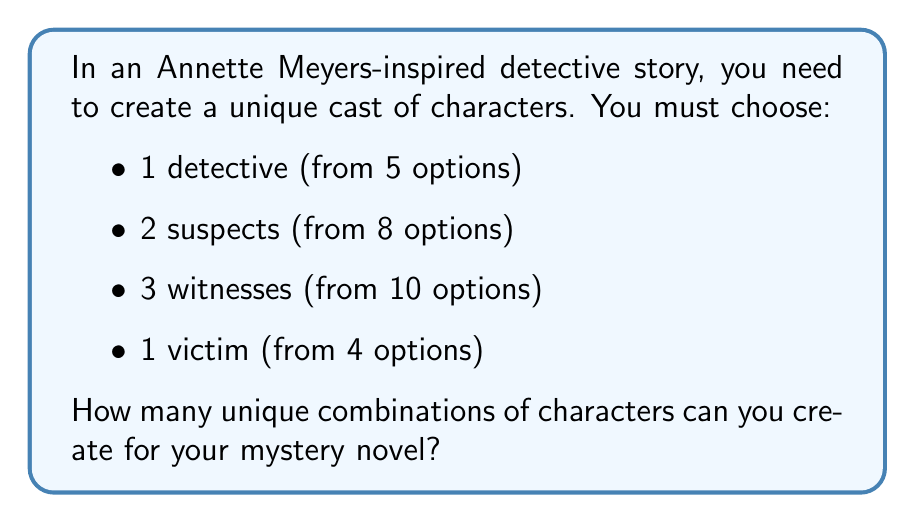What is the answer to this math problem? Let's break this down step-by-step:

1. For the detective:
   We have 5 options, and we need to choose 1. This is a straightforward choice:
   $$ \text{Detective combinations} = 5 $$

2. For the suspects:
   We need to choose 2 from 8 options. This is a combination problem:
   $$ \text{Suspect combinations} = \binom{8}{2} = \frac{8!}{2!(8-2)!} = \frac{8 \cdot 7}{2 \cdot 1} = 28 $$

3. For the witnesses:
   We need to choose 3 from 10 options. Again, this is a combination:
   $$ \text{Witness combinations} = \binom{10}{3} = \frac{10!}{3!(10-3)!} = \frac{10 \cdot 9 \cdot 8}{3 \cdot 2 \cdot 1} = 120 $$

4. For the victim:
   We have 4 options, and we need to choose 1:
   $$ \text{Victim combinations} = 4 $$

5. To get the total number of unique combinations, we multiply these together:
   $$ \text{Total combinations} = 5 \cdot 28 \cdot 120 \cdot 4 = 67,200 $$

This multiplication follows the multiplication principle of counting, as each choice is independent of the others.
Answer: 67,200 